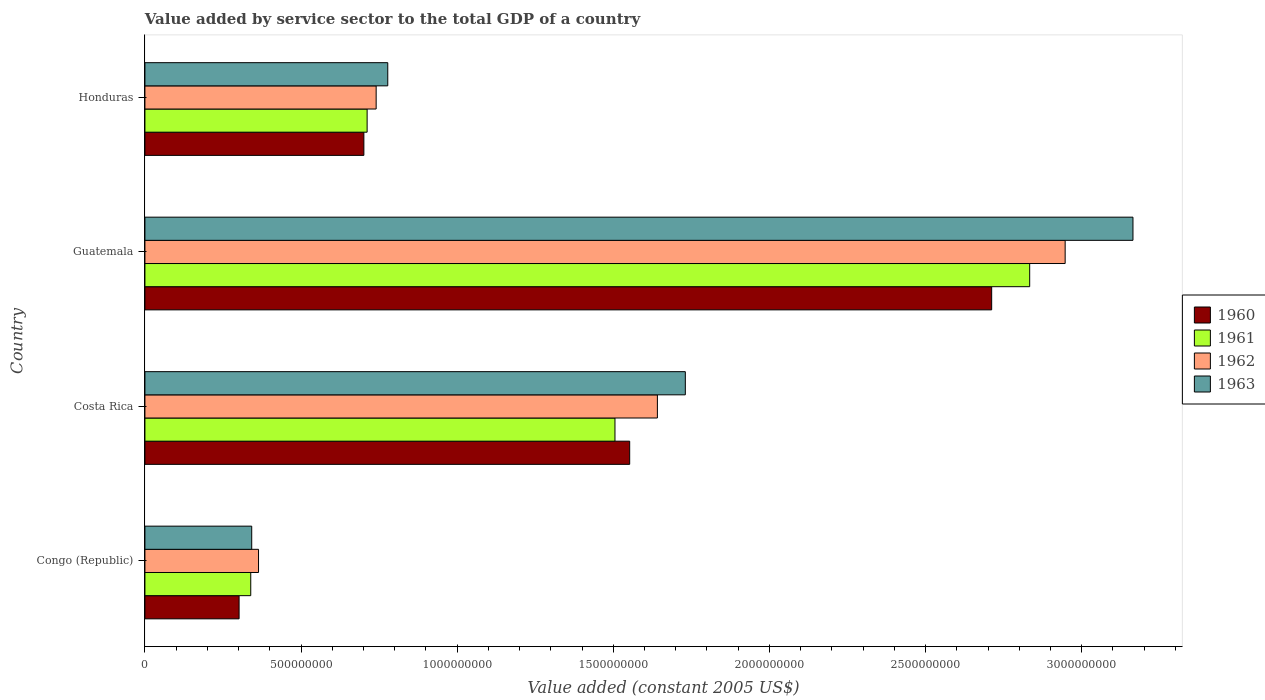Are the number of bars per tick equal to the number of legend labels?
Make the answer very short. Yes. Are the number of bars on each tick of the Y-axis equal?
Offer a terse response. Yes. What is the label of the 4th group of bars from the top?
Offer a terse response. Congo (Republic). What is the value added by service sector in 1962 in Costa Rica?
Your answer should be compact. 1.64e+09. Across all countries, what is the maximum value added by service sector in 1962?
Offer a terse response. 2.95e+09. Across all countries, what is the minimum value added by service sector in 1960?
Offer a terse response. 3.02e+08. In which country was the value added by service sector in 1962 maximum?
Your answer should be very brief. Guatemala. In which country was the value added by service sector in 1961 minimum?
Your response must be concise. Congo (Republic). What is the total value added by service sector in 1960 in the graph?
Give a very brief answer. 5.27e+09. What is the difference between the value added by service sector in 1962 in Congo (Republic) and that in Honduras?
Give a very brief answer. -3.77e+08. What is the difference between the value added by service sector in 1963 in Congo (Republic) and the value added by service sector in 1961 in Honduras?
Keep it short and to the point. -3.70e+08. What is the average value added by service sector in 1960 per country?
Ensure brevity in your answer.  1.32e+09. What is the difference between the value added by service sector in 1961 and value added by service sector in 1962 in Honduras?
Your response must be concise. -2.89e+07. In how many countries, is the value added by service sector in 1962 greater than 400000000 US$?
Provide a short and direct response. 3. What is the ratio of the value added by service sector in 1962 in Costa Rica to that in Guatemala?
Provide a short and direct response. 0.56. Is the difference between the value added by service sector in 1961 in Congo (Republic) and Guatemala greater than the difference between the value added by service sector in 1962 in Congo (Republic) and Guatemala?
Offer a terse response. Yes. What is the difference between the highest and the second highest value added by service sector in 1961?
Offer a very short reply. 1.33e+09. What is the difference between the highest and the lowest value added by service sector in 1963?
Offer a terse response. 2.82e+09. In how many countries, is the value added by service sector in 1962 greater than the average value added by service sector in 1962 taken over all countries?
Make the answer very short. 2. Is it the case that in every country, the sum of the value added by service sector in 1963 and value added by service sector in 1962 is greater than the sum of value added by service sector in 1961 and value added by service sector in 1960?
Provide a short and direct response. No. What does the 3rd bar from the top in Costa Rica represents?
Your answer should be very brief. 1961. What does the 3rd bar from the bottom in Costa Rica represents?
Offer a terse response. 1962. How many bars are there?
Give a very brief answer. 16. How many countries are there in the graph?
Your answer should be very brief. 4. What is the difference between two consecutive major ticks on the X-axis?
Your answer should be very brief. 5.00e+08. Where does the legend appear in the graph?
Offer a very short reply. Center right. How are the legend labels stacked?
Offer a very short reply. Vertical. What is the title of the graph?
Provide a short and direct response. Value added by service sector to the total GDP of a country. Does "1975" appear as one of the legend labels in the graph?
Your answer should be very brief. No. What is the label or title of the X-axis?
Provide a short and direct response. Value added (constant 2005 US$). What is the Value added (constant 2005 US$) in 1960 in Congo (Republic)?
Offer a terse response. 3.02e+08. What is the Value added (constant 2005 US$) of 1961 in Congo (Republic)?
Your answer should be compact. 3.39e+08. What is the Value added (constant 2005 US$) of 1962 in Congo (Republic)?
Provide a succinct answer. 3.64e+08. What is the Value added (constant 2005 US$) in 1963 in Congo (Republic)?
Offer a very short reply. 3.42e+08. What is the Value added (constant 2005 US$) of 1960 in Costa Rica?
Give a very brief answer. 1.55e+09. What is the Value added (constant 2005 US$) in 1961 in Costa Rica?
Your answer should be compact. 1.51e+09. What is the Value added (constant 2005 US$) in 1962 in Costa Rica?
Provide a succinct answer. 1.64e+09. What is the Value added (constant 2005 US$) of 1963 in Costa Rica?
Offer a very short reply. 1.73e+09. What is the Value added (constant 2005 US$) in 1960 in Guatemala?
Ensure brevity in your answer.  2.71e+09. What is the Value added (constant 2005 US$) of 1961 in Guatemala?
Your answer should be very brief. 2.83e+09. What is the Value added (constant 2005 US$) in 1962 in Guatemala?
Make the answer very short. 2.95e+09. What is the Value added (constant 2005 US$) of 1963 in Guatemala?
Keep it short and to the point. 3.16e+09. What is the Value added (constant 2005 US$) in 1960 in Honduras?
Keep it short and to the point. 7.01e+08. What is the Value added (constant 2005 US$) of 1961 in Honduras?
Offer a very short reply. 7.12e+08. What is the Value added (constant 2005 US$) of 1962 in Honduras?
Ensure brevity in your answer.  7.41e+08. What is the Value added (constant 2005 US$) of 1963 in Honduras?
Make the answer very short. 7.78e+08. Across all countries, what is the maximum Value added (constant 2005 US$) in 1960?
Make the answer very short. 2.71e+09. Across all countries, what is the maximum Value added (constant 2005 US$) of 1961?
Your answer should be very brief. 2.83e+09. Across all countries, what is the maximum Value added (constant 2005 US$) in 1962?
Provide a short and direct response. 2.95e+09. Across all countries, what is the maximum Value added (constant 2005 US$) in 1963?
Keep it short and to the point. 3.16e+09. Across all countries, what is the minimum Value added (constant 2005 US$) of 1960?
Keep it short and to the point. 3.02e+08. Across all countries, what is the minimum Value added (constant 2005 US$) of 1961?
Offer a very short reply. 3.39e+08. Across all countries, what is the minimum Value added (constant 2005 US$) in 1962?
Provide a succinct answer. 3.64e+08. Across all countries, what is the minimum Value added (constant 2005 US$) of 1963?
Give a very brief answer. 3.42e+08. What is the total Value added (constant 2005 US$) of 1960 in the graph?
Ensure brevity in your answer.  5.27e+09. What is the total Value added (constant 2005 US$) in 1961 in the graph?
Provide a short and direct response. 5.39e+09. What is the total Value added (constant 2005 US$) in 1962 in the graph?
Give a very brief answer. 5.69e+09. What is the total Value added (constant 2005 US$) in 1963 in the graph?
Your answer should be compact. 6.01e+09. What is the difference between the Value added (constant 2005 US$) of 1960 in Congo (Republic) and that in Costa Rica?
Make the answer very short. -1.25e+09. What is the difference between the Value added (constant 2005 US$) of 1961 in Congo (Republic) and that in Costa Rica?
Your response must be concise. -1.17e+09. What is the difference between the Value added (constant 2005 US$) of 1962 in Congo (Republic) and that in Costa Rica?
Provide a short and direct response. -1.28e+09. What is the difference between the Value added (constant 2005 US$) of 1963 in Congo (Republic) and that in Costa Rica?
Your answer should be very brief. -1.39e+09. What is the difference between the Value added (constant 2005 US$) in 1960 in Congo (Republic) and that in Guatemala?
Provide a succinct answer. -2.41e+09. What is the difference between the Value added (constant 2005 US$) of 1961 in Congo (Republic) and that in Guatemala?
Give a very brief answer. -2.49e+09. What is the difference between the Value added (constant 2005 US$) of 1962 in Congo (Republic) and that in Guatemala?
Your answer should be very brief. -2.58e+09. What is the difference between the Value added (constant 2005 US$) in 1963 in Congo (Republic) and that in Guatemala?
Provide a succinct answer. -2.82e+09. What is the difference between the Value added (constant 2005 US$) of 1960 in Congo (Republic) and that in Honduras?
Provide a succinct answer. -4.00e+08. What is the difference between the Value added (constant 2005 US$) of 1961 in Congo (Republic) and that in Honduras?
Provide a short and direct response. -3.73e+08. What is the difference between the Value added (constant 2005 US$) of 1962 in Congo (Republic) and that in Honduras?
Give a very brief answer. -3.77e+08. What is the difference between the Value added (constant 2005 US$) in 1963 in Congo (Republic) and that in Honduras?
Your response must be concise. -4.36e+08. What is the difference between the Value added (constant 2005 US$) in 1960 in Costa Rica and that in Guatemala?
Your response must be concise. -1.16e+09. What is the difference between the Value added (constant 2005 US$) in 1961 in Costa Rica and that in Guatemala?
Make the answer very short. -1.33e+09. What is the difference between the Value added (constant 2005 US$) of 1962 in Costa Rica and that in Guatemala?
Ensure brevity in your answer.  -1.31e+09. What is the difference between the Value added (constant 2005 US$) of 1963 in Costa Rica and that in Guatemala?
Your answer should be compact. -1.43e+09. What is the difference between the Value added (constant 2005 US$) in 1960 in Costa Rica and that in Honduras?
Your answer should be compact. 8.51e+08. What is the difference between the Value added (constant 2005 US$) in 1961 in Costa Rica and that in Honduras?
Offer a very short reply. 7.94e+08. What is the difference between the Value added (constant 2005 US$) in 1962 in Costa Rica and that in Honduras?
Make the answer very short. 9.01e+08. What is the difference between the Value added (constant 2005 US$) in 1963 in Costa Rica and that in Honduras?
Your response must be concise. 9.53e+08. What is the difference between the Value added (constant 2005 US$) of 1960 in Guatemala and that in Honduras?
Your answer should be compact. 2.01e+09. What is the difference between the Value added (constant 2005 US$) in 1961 in Guatemala and that in Honduras?
Provide a succinct answer. 2.12e+09. What is the difference between the Value added (constant 2005 US$) in 1962 in Guatemala and that in Honduras?
Make the answer very short. 2.21e+09. What is the difference between the Value added (constant 2005 US$) of 1963 in Guatemala and that in Honduras?
Provide a short and direct response. 2.39e+09. What is the difference between the Value added (constant 2005 US$) in 1960 in Congo (Republic) and the Value added (constant 2005 US$) in 1961 in Costa Rica?
Your response must be concise. -1.20e+09. What is the difference between the Value added (constant 2005 US$) of 1960 in Congo (Republic) and the Value added (constant 2005 US$) of 1962 in Costa Rica?
Your answer should be very brief. -1.34e+09. What is the difference between the Value added (constant 2005 US$) in 1960 in Congo (Republic) and the Value added (constant 2005 US$) in 1963 in Costa Rica?
Provide a short and direct response. -1.43e+09. What is the difference between the Value added (constant 2005 US$) of 1961 in Congo (Republic) and the Value added (constant 2005 US$) of 1962 in Costa Rica?
Offer a very short reply. -1.30e+09. What is the difference between the Value added (constant 2005 US$) of 1961 in Congo (Republic) and the Value added (constant 2005 US$) of 1963 in Costa Rica?
Provide a succinct answer. -1.39e+09. What is the difference between the Value added (constant 2005 US$) of 1962 in Congo (Republic) and the Value added (constant 2005 US$) of 1963 in Costa Rica?
Keep it short and to the point. -1.37e+09. What is the difference between the Value added (constant 2005 US$) of 1960 in Congo (Republic) and the Value added (constant 2005 US$) of 1961 in Guatemala?
Provide a succinct answer. -2.53e+09. What is the difference between the Value added (constant 2005 US$) of 1960 in Congo (Republic) and the Value added (constant 2005 US$) of 1962 in Guatemala?
Give a very brief answer. -2.65e+09. What is the difference between the Value added (constant 2005 US$) in 1960 in Congo (Republic) and the Value added (constant 2005 US$) in 1963 in Guatemala?
Provide a short and direct response. -2.86e+09. What is the difference between the Value added (constant 2005 US$) in 1961 in Congo (Republic) and the Value added (constant 2005 US$) in 1962 in Guatemala?
Your response must be concise. -2.61e+09. What is the difference between the Value added (constant 2005 US$) of 1961 in Congo (Republic) and the Value added (constant 2005 US$) of 1963 in Guatemala?
Offer a terse response. -2.83e+09. What is the difference between the Value added (constant 2005 US$) of 1962 in Congo (Republic) and the Value added (constant 2005 US$) of 1963 in Guatemala?
Offer a very short reply. -2.80e+09. What is the difference between the Value added (constant 2005 US$) of 1960 in Congo (Republic) and the Value added (constant 2005 US$) of 1961 in Honduras?
Provide a short and direct response. -4.10e+08. What is the difference between the Value added (constant 2005 US$) in 1960 in Congo (Republic) and the Value added (constant 2005 US$) in 1962 in Honduras?
Your response must be concise. -4.39e+08. What is the difference between the Value added (constant 2005 US$) of 1960 in Congo (Republic) and the Value added (constant 2005 US$) of 1963 in Honduras?
Provide a short and direct response. -4.76e+08. What is the difference between the Value added (constant 2005 US$) of 1961 in Congo (Republic) and the Value added (constant 2005 US$) of 1962 in Honduras?
Provide a short and direct response. -4.02e+08. What is the difference between the Value added (constant 2005 US$) in 1961 in Congo (Republic) and the Value added (constant 2005 US$) in 1963 in Honduras?
Provide a short and direct response. -4.39e+08. What is the difference between the Value added (constant 2005 US$) in 1962 in Congo (Republic) and the Value added (constant 2005 US$) in 1963 in Honduras?
Provide a short and direct response. -4.14e+08. What is the difference between the Value added (constant 2005 US$) in 1960 in Costa Rica and the Value added (constant 2005 US$) in 1961 in Guatemala?
Offer a very short reply. -1.28e+09. What is the difference between the Value added (constant 2005 US$) in 1960 in Costa Rica and the Value added (constant 2005 US$) in 1962 in Guatemala?
Make the answer very short. -1.39e+09. What is the difference between the Value added (constant 2005 US$) in 1960 in Costa Rica and the Value added (constant 2005 US$) in 1963 in Guatemala?
Offer a terse response. -1.61e+09. What is the difference between the Value added (constant 2005 US$) of 1961 in Costa Rica and the Value added (constant 2005 US$) of 1962 in Guatemala?
Your answer should be very brief. -1.44e+09. What is the difference between the Value added (constant 2005 US$) in 1961 in Costa Rica and the Value added (constant 2005 US$) in 1963 in Guatemala?
Provide a short and direct response. -1.66e+09. What is the difference between the Value added (constant 2005 US$) of 1962 in Costa Rica and the Value added (constant 2005 US$) of 1963 in Guatemala?
Your answer should be very brief. -1.52e+09. What is the difference between the Value added (constant 2005 US$) of 1960 in Costa Rica and the Value added (constant 2005 US$) of 1961 in Honduras?
Your answer should be very brief. 8.41e+08. What is the difference between the Value added (constant 2005 US$) in 1960 in Costa Rica and the Value added (constant 2005 US$) in 1962 in Honduras?
Your response must be concise. 8.12e+08. What is the difference between the Value added (constant 2005 US$) of 1960 in Costa Rica and the Value added (constant 2005 US$) of 1963 in Honduras?
Offer a very short reply. 7.75e+08. What is the difference between the Value added (constant 2005 US$) of 1961 in Costa Rica and the Value added (constant 2005 US$) of 1962 in Honduras?
Provide a succinct answer. 7.65e+08. What is the difference between the Value added (constant 2005 US$) in 1961 in Costa Rica and the Value added (constant 2005 US$) in 1963 in Honduras?
Keep it short and to the point. 7.28e+08. What is the difference between the Value added (constant 2005 US$) in 1962 in Costa Rica and the Value added (constant 2005 US$) in 1963 in Honduras?
Ensure brevity in your answer.  8.63e+08. What is the difference between the Value added (constant 2005 US$) in 1960 in Guatemala and the Value added (constant 2005 US$) in 1961 in Honduras?
Your response must be concise. 2.00e+09. What is the difference between the Value added (constant 2005 US$) of 1960 in Guatemala and the Value added (constant 2005 US$) of 1962 in Honduras?
Your answer should be very brief. 1.97e+09. What is the difference between the Value added (constant 2005 US$) of 1960 in Guatemala and the Value added (constant 2005 US$) of 1963 in Honduras?
Offer a very short reply. 1.93e+09. What is the difference between the Value added (constant 2005 US$) of 1961 in Guatemala and the Value added (constant 2005 US$) of 1962 in Honduras?
Your answer should be very brief. 2.09e+09. What is the difference between the Value added (constant 2005 US$) in 1961 in Guatemala and the Value added (constant 2005 US$) in 1963 in Honduras?
Offer a very short reply. 2.06e+09. What is the difference between the Value added (constant 2005 US$) of 1962 in Guatemala and the Value added (constant 2005 US$) of 1963 in Honduras?
Provide a succinct answer. 2.17e+09. What is the average Value added (constant 2005 US$) in 1960 per country?
Provide a succinct answer. 1.32e+09. What is the average Value added (constant 2005 US$) of 1961 per country?
Your answer should be compact. 1.35e+09. What is the average Value added (constant 2005 US$) of 1962 per country?
Make the answer very short. 1.42e+09. What is the average Value added (constant 2005 US$) of 1963 per country?
Give a very brief answer. 1.50e+09. What is the difference between the Value added (constant 2005 US$) in 1960 and Value added (constant 2005 US$) in 1961 in Congo (Republic)?
Provide a short and direct response. -3.74e+07. What is the difference between the Value added (constant 2005 US$) of 1960 and Value added (constant 2005 US$) of 1962 in Congo (Republic)?
Make the answer very short. -6.23e+07. What is the difference between the Value added (constant 2005 US$) of 1960 and Value added (constant 2005 US$) of 1963 in Congo (Republic)?
Offer a terse response. -4.05e+07. What is the difference between the Value added (constant 2005 US$) of 1961 and Value added (constant 2005 US$) of 1962 in Congo (Republic)?
Give a very brief answer. -2.49e+07. What is the difference between the Value added (constant 2005 US$) of 1961 and Value added (constant 2005 US$) of 1963 in Congo (Republic)?
Provide a succinct answer. -3.09e+06. What is the difference between the Value added (constant 2005 US$) in 1962 and Value added (constant 2005 US$) in 1963 in Congo (Republic)?
Ensure brevity in your answer.  2.18e+07. What is the difference between the Value added (constant 2005 US$) in 1960 and Value added (constant 2005 US$) in 1961 in Costa Rica?
Offer a very short reply. 4.72e+07. What is the difference between the Value added (constant 2005 US$) in 1960 and Value added (constant 2005 US$) in 1962 in Costa Rica?
Keep it short and to the point. -8.87e+07. What is the difference between the Value added (constant 2005 US$) of 1960 and Value added (constant 2005 US$) of 1963 in Costa Rica?
Make the answer very short. -1.78e+08. What is the difference between the Value added (constant 2005 US$) in 1961 and Value added (constant 2005 US$) in 1962 in Costa Rica?
Keep it short and to the point. -1.36e+08. What is the difference between the Value added (constant 2005 US$) in 1961 and Value added (constant 2005 US$) in 1963 in Costa Rica?
Ensure brevity in your answer.  -2.25e+08. What is the difference between the Value added (constant 2005 US$) in 1962 and Value added (constant 2005 US$) in 1963 in Costa Rica?
Make the answer very short. -8.94e+07. What is the difference between the Value added (constant 2005 US$) of 1960 and Value added (constant 2005 US$) of 1961 in Guatemala?
Keep it short and to the point. -1.22e+08. What is the difference between the Value added (constant 2005 US$) in 1960 and Value added (constant 2005 US$) in 1962 in Guatemala?
Make the answer very short. -2.35e+08. What is the difference between the Value added (constant 2005 US$) in 1960 and Value added (constant 2005 US$) in 1963 in Guatemala?
Give a very brief answer. -4.53e+08. What is the difference between the Value added (constant 2005 US$) in 1961 and Value added (constant 2005 US$) in 1962 in Guatemala?
Your answer should be compact. -1.14e+08. What is the difference between the Value added (constant 2005 US$) in 1961 and Value added (constant 2005 US$) in 1963 in Guatemala?
Ensure brevity in your answer.  -3.31e+08. What is the difference between the Value added (constant 2005 US$) of 1962 and Value added (constant 2005 US$) of 1963 in Guatemala?
Your answer should be compact. -2.17e+08. What is the difference between the Value added (constant 2005 US$) in 1960 and Value added (constant 2005 US$) in 1961 in Honduras?
Offer a very short reply. -1.04e+07. What is the difference between the Value added (constant 2005 US$) in 1960 and Value added (constant 2005 US$) in 1962 in Honduras?
Keep it short and to the point. -3.93e+07. What is the difference between the Value added (constant 2005 US$) in 1960 and Value added (constant 2005 US$) in 1963 in Honduras?
Offer a terse response. -7.65e+07. What is the difference between the Value added (constant 2005 US$) in 1961 and Value added (constant 2005 US$) in 1962 in Honduras?
Your response must be concise. -2.89e+07. What is the difference between the Value added (constant 2005 US$) of 1961 and Value added (constant 2005 US$) of 1963 in Honduras?
Provide a succinct answer. -6.62e+07. What is the difference between the Value added (constant 2005 US$) of 1962 and Value added (constant 2005 US$) of 1963 in Honduras?
Your answer should be very brief. -3.72e+07. What is the ratio of the Value added (constant 2005 US$) of 1960 in Congo (Republic) to that in Costa Rica?
Your answer should be compact. 0.19. What is the ratio of the Value added (constant 2005 US$) of 1961 in Congo (Republic) to that in Costa Rica?
Ensure brevity in your answer.  0.23. What is the ratio of the Value added (constant 2005 US$) in 1962 in Congo (Republic) to that in Costa Rica?
Make the answer very short. 0.22. What is the ratio of the Value added (constant 2005 US$) of 1963 in Congo (Republic) to that in Costa Rica?
Your answer should be very brief. 0.2. What is the ratio of the Value added (constant 2005 US$) in 1960 in Congo (Republic) to that in Guatemala?
Offer a terse response. 0.11. What is the ratio of the Value added (constant 2005 US$) in 1961 in Congo (Republic) to that in Guatemala?
Make the answer very short. 0.12. What is the ratio of the Value added (constant 2005 US$) in 1962 in Congo (Republic) to that in Guatemala?
Provide a short and direct response. 0.12. What is the ratio of the Value added (constant 2005 US$) in 1963 in Congo (Republic) to that in Guatemala?
Ensure brevity in your answer.  0.11. What is the ratio of the Value added (constant 2005 US$) in 1960 in Congo (Republic) to that in Honduras?
Your response must be concise. 0.43. What is the ratio of the Value added (constant 2005 US$) of 1961 in Congo (Republic) to that in Honduras?
Make the answer very short. 0.48. What is the ratio of the Value added (constant 2005 US$) of 1962 in Congo (Republic) to that in Honduras?
Give a very brief answer. 0.49. What is the ratio of the Value added (constant 2005 US$) in 1963 in Congo (Republic) to that in Honduras?
Your answer should be very brief. 0.44. What is the ratio of the Value added (constant 2005 US$) in 1960 in Costa Rica to that in Guatemala?
Offer a very short reply. 0.57. What is the ratio of the Value added (constant 2005 US$) in 1961 in Costa Rica to that in Guatemala?
Make the answer very short. 0.53. What is the ratio of the Value added (constant 2005 US$) of 1962 in Costa Rica to that in Guatemala?
Keep it short and to the point. 0.56. What is the ratio of the Value added (constant 2005 US$) of 1963 in Costa Rica to that in Guatemala?
Make the answer very short. 0.55. What is the ratio of the Value added (constant 2005 US$) in 1960 in Costa Rica to that in Honduras?
Give a very brief answer. 2.21. What is the ratio of the Value added (constant 2005 US$) of 1961 in Costa Rica to that in Honduras?
Provide a short and direct response. 2.12. What is the ratio of the Value added (constant 2005 US$) of 1962 in Costa Rica to that in Honduras?
Give a very brief answer. 2.22. What is the ratio of the Value added (constant 2005 US$) of 1963 in Costa Rica to that in Honduras?
Give a very brief answer. 2.23. What is the ratio of the Value added (constant 2005 US$) in 1960 in Guatemala to that in Honduras?
Your response must be concise. 3.87. What is the ratio of the Value added (constant 2005 US$) of 1961 in Guatemala to that in Honduras?
Offer a terse response. 3.98. What is the ratio of the Value added (constant 2005 US$) in 1962 in Guatemala to that in Honduras?
Make the answer very short. 3.98. What is the ratio of the Value added (constant 2005 US$) in 1963 in Guatemala to that in Honduras?
Offer a very short reply. 4.07. What is the difference between the highest and the second highest Value added (constant 2005 US$) of 1960?
Make the answer very short. 1.16e+09. What is the difference between the highest and the second highest Value added (constant 2005 US$) of 1961?
Keep it short and to the point. 1.33e+09. What is the difference between the highest and the second highest Value added (constant 2005 US$) of 1962?
Your answer should be compact. 1.31e+09. What is the difference between the highest and the second highest Value added (constant 2005 US$) of 1963?
Provide a short and direct response. 1.43e+09. What is the difference between the highest and the lowest Value added (constant 2005 US$) of 1960?
Give a very brief answer. 2.41e+09. What is the difference between the highest and the lowest Value added (constant 2005 US$) of 1961?
Give a very brief answer. 2.49e+09. What is the difference between the highest and the lowest Value added (constant 2005 US$) in 1962?
Your response must be concise. 2.58e+09. What is the difference between the highest and the lowest Value added (constant 2005 US$) of 1963?
Give a very brief answer. 2.82e+09. 